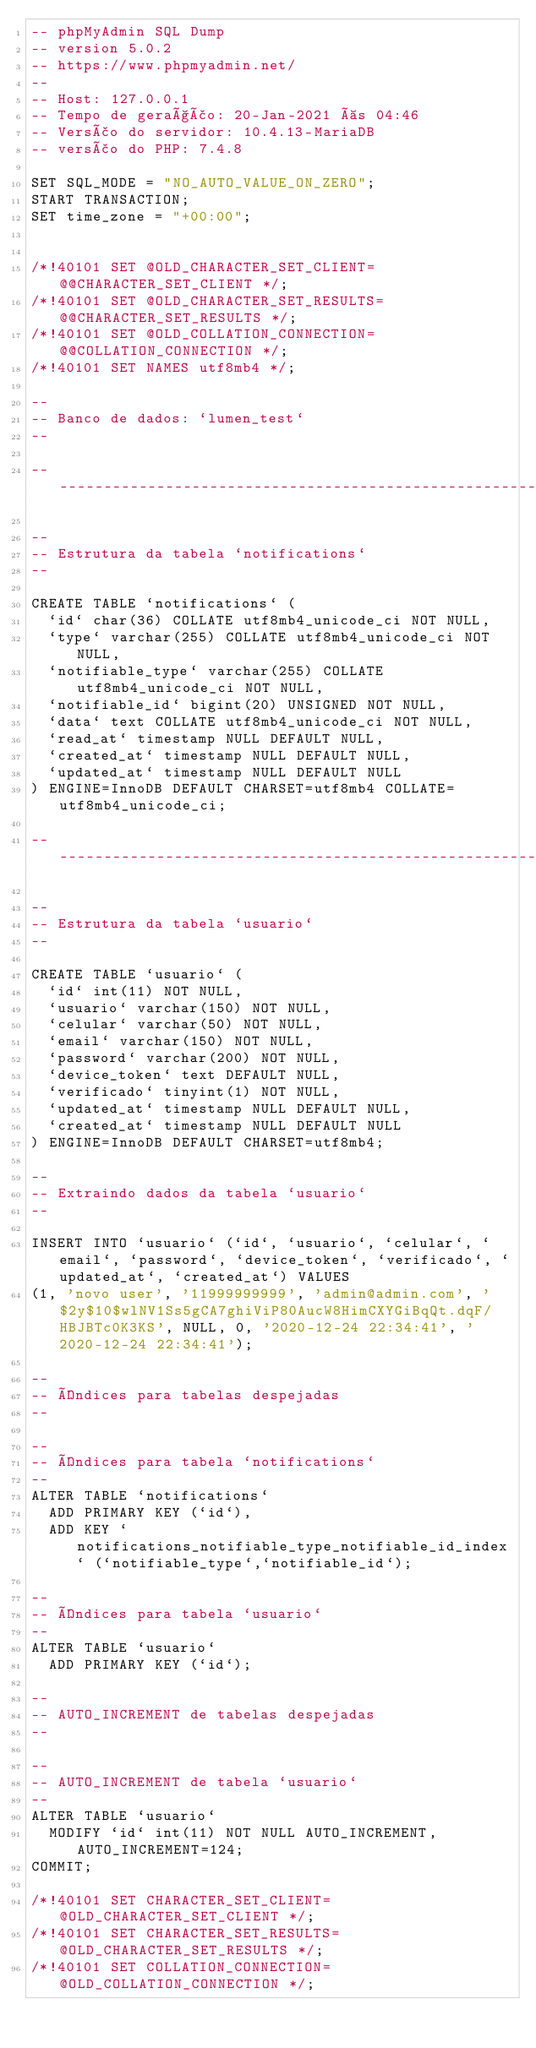Convert code to text. <code><loc_0><loc_0><loc_500><loc_500><_SQL_>-- phpMyAdmin SQL Dump
-- version 5.0.2
-- https://www.phpmyadmin.net/
--
-- Host: 127.0.0.1
-- Tempo de geração: 20-Jan-2021 às 04:46
-- Versão do servidor: 10.4.13-MariaDB
-- versão do PHP: 7.4.8

SET SQL_MODE = "NO_AUTO_VALUE_ON_ZERO";
START TRANSACTION;
SET time_zone = "+00:00";


/*!40101 SET @OLD_CHARACTER_SET_CLIENT=@@CHARACTER_SET_CLIENT */;
/*!40101 SET @OLD_CHARACTER_SET_RESULTS=@@CHARACTER_SET_RESULTS */;
/*!40101 SET @OLD_COLLATION_CONNECTION=@@COLLATION_CONNECTION */;
/*!40101 SET NAMES utf8mb4 */;

--
-- Banco de dados: `lumen_test`
--

-- --------------------------------------------------------

--
-- Estrutura da tabela `notifications`
--

CREATE TABLE `notifications` (
  `id` char(36) COLLATE utf8mb4_unicode_ci NOT NULL,
  `type` varchar(255) COLLATE utf8mb4_unicode_ci NOT NULL,
  `notifiable_type` varchar(255) COLLATE utf8mb4_unicode_ci NOT NULL,
  `notifiable_id` bigint(20) UNSIGNED NOT NULL,
  `data` text COLLATE utf8mb4_unicode_ci NOT NULL,
  `read_at` timestamp NULL DEFAULT NULL,
  `created_at` timestamp NULL DEFAULT NULL,
  `updated_at` timestamp NULL DEFAULT NULL
) ENGINE=InnoDB DEFAULT CHARSET=utf8mb4 COLLATE=utf8mb4_unicode_ci;

-- --------------------------------------------------------

--
-- Estrutura da tabela `usuario`
--

CREATE TABLE `usuario` (
  `id` int(11) NOT NULL,
  `usuario` varchar(150) NOT NULL,
  `celular` varchar(50) NOT NULL,
  `email` varchar(150) NOT NULL,
  `password` varchar(200) NOT NULL,
  `device_token` text DEFAULT NULL,
  `verificado` tinyint(1) NOT NULL,
  `updated_at` timestamp NULL DEFAULT NULL,
  `created_at` timestamp NULL DEFAULT NULL
) ENGINE=InnoDB DEFAULT CHARSET=utf8mb4;

--
-- Extraindo dados da tabela `usuario`
--

INSERT INTO `usuario` (`id`, `usuario`, `celular`, `email`, `password`, `device_token`, `verificado`, `updated_at`, `created_at`) VALUES
(1, 'novo user', '11999999999', 'admin@admin.com', '$2y$10$wlNV1Ss5gCA7ghiViP80AucW8HimCXYGiBqQt.dqF/HBJBTc0K3KS', NULL, 0, '2020-12-24 22:34:41', '2020-12-24 22:34:41');

--
-- Índices para tabelas despejadas
--

--
-- Índices para tabela `notifications`
--
ALTER TABLE `notifications`
  ADD PRIMARY KEY (`id`),
  ADD KEY `notifications_notifiable_type_notifiable_id_index` (`notifiable_type`,`notifiable_id`);

--
-- Índices para tabela `usuario`
--
ALTER TABLE `usuario`
  ADD PRIMARY KEY (`id`);

--
-- AUTO_INCREMENT de tabelas despejadas
--

--
-- AUTO_INCREMENT de tabela `usuario`
--
ALTER TABLE `usuario`
  MODIFY `id` int(11) NOT NULL AUTO_INCREMENT, AUTO_INCREMENT=124;
COMMIT;

/*!40101 SET CHARACTER_SET_CLIENT=@OLD_CHARACTER_SET_CLIENT */;
/*!40101 SET CHARACTER_SET_RESULTS=@OLD_CHARACTER_SET_RESULTS */;
/*!40101 SET COLLATION_CONNECTION=@OLD_COLLATION_CONNECTION */;
</code> 